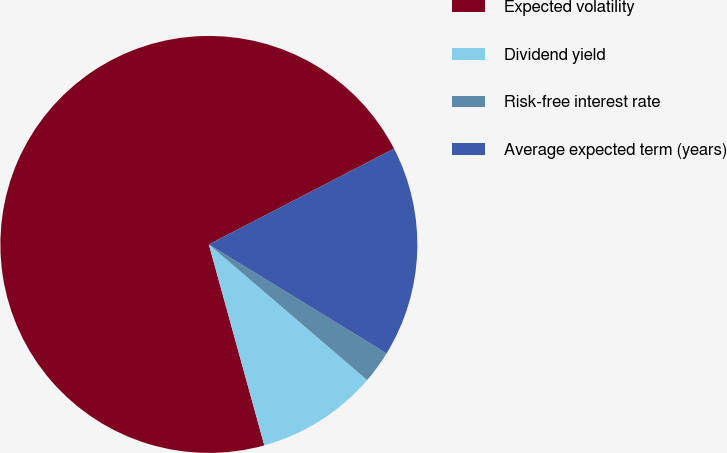<chart> <loc_0><loc_0><loc_500><loc_500><pie_chart><fcel>Expected volatility<fcel>Dividend yield<fcel>Risk-free interest rate<fcel>Average expected term (years)<nl><fcel>71.69%<fcel>9.44%<fcel>2.52%<fcel>16.35%<nl></chart> 